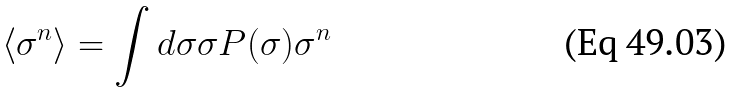Convert formula to latex. <formula><loc_0><loc_0><loc_500><loc_500>\left < \sigma ^ { n } \right > = \int d \sigma \sigma P ( \sigma ) \sigma ^ { n }</formula> 